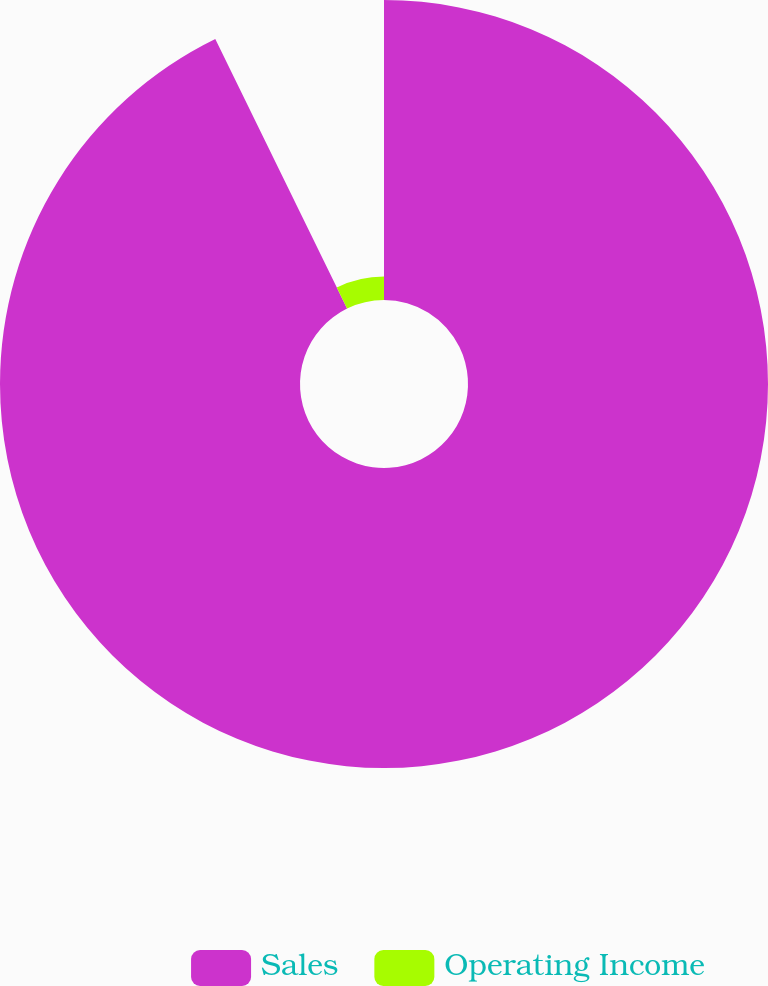Convert chart to OTSL. <chart><loc_0><loc_0><loc_500><loc_500><pie_chart><fcel>Sales<fcel>Operating Income<nl><fcel>92.76%<fcel>7.24%<nl></chart> 